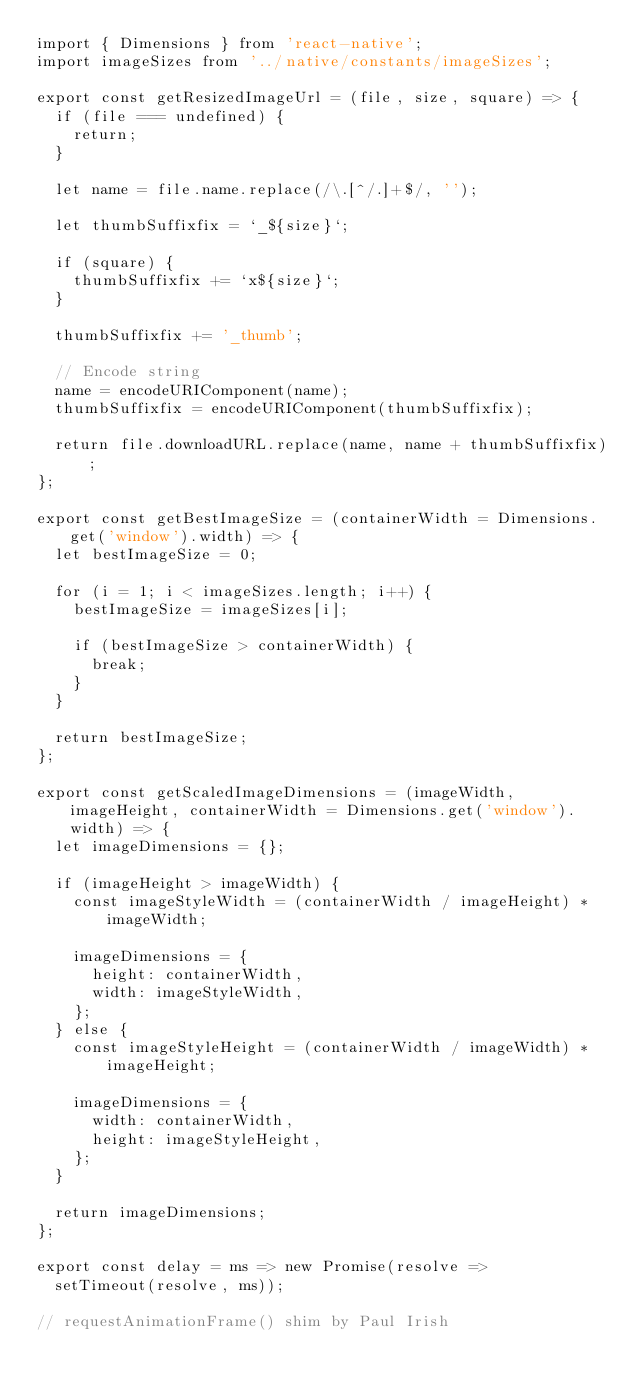<code> <loc_0><loc_0><loc_500><loc_500><_JavaScript_>import { Dimensions } from 'react-native';
import imageSizes from '../native/constants/imageSizes';

export const getResizedImageUrl = (file, size, square) => {
  if (file === undefined) {
    return;
  }

  let name = file.name.replace(/\.[^/.]+$/, '');

  let thumbSuffixfix = `_${size}`;

  if (square) {
    thumbSuffixfix += `x${size}`;
  }

  thumbSuffixfix += '_thumb';

  // Encode string
  name = encodeURIComponent(name);
  thumbSuffixfix = encodeURIComponent(thumbSuffixfix);

  return file.downloadURL.replace(name, name + thumbSuffixfix);
};

export const getBestImageSize = (containerWidth = Dimensions.get('window').width) => {
  let bestImageSize = 0;

  for (i = 1; i < imageSizes.length; i++) {
    bestImageSize = imageSizes[i];

    if (bestImageSize > containerWidth) {
      break;
    }
  }

  return bestImageSize;
};

export const getScaledImageDimensions = (imageWidth, imageHeight, containerWidth = Dimensions.get('window').width) => {
  let imageDimensions = {};

  if (imageHeight > imageWidth) {
    const imageStyleWidth = (containerWidth / imageHeight) * imageWidth;

    imageDimensions = {
      height: containerWidth,
      width: imageStyleWidth,
    };
  } else {
    const imageStyleHeight = (containerWidth / imageWidth) * imageHeight;

    imageDimensions = {
      width: containerWidth,
      height: imageStyleHeight,
    };
  }

  return imageDimensions;
};

export const delay = ms => new Promise(resolve =>
  setTimeout(resolve, ms));

// requestAnimationFrame() shim by Paul Irish</code> 